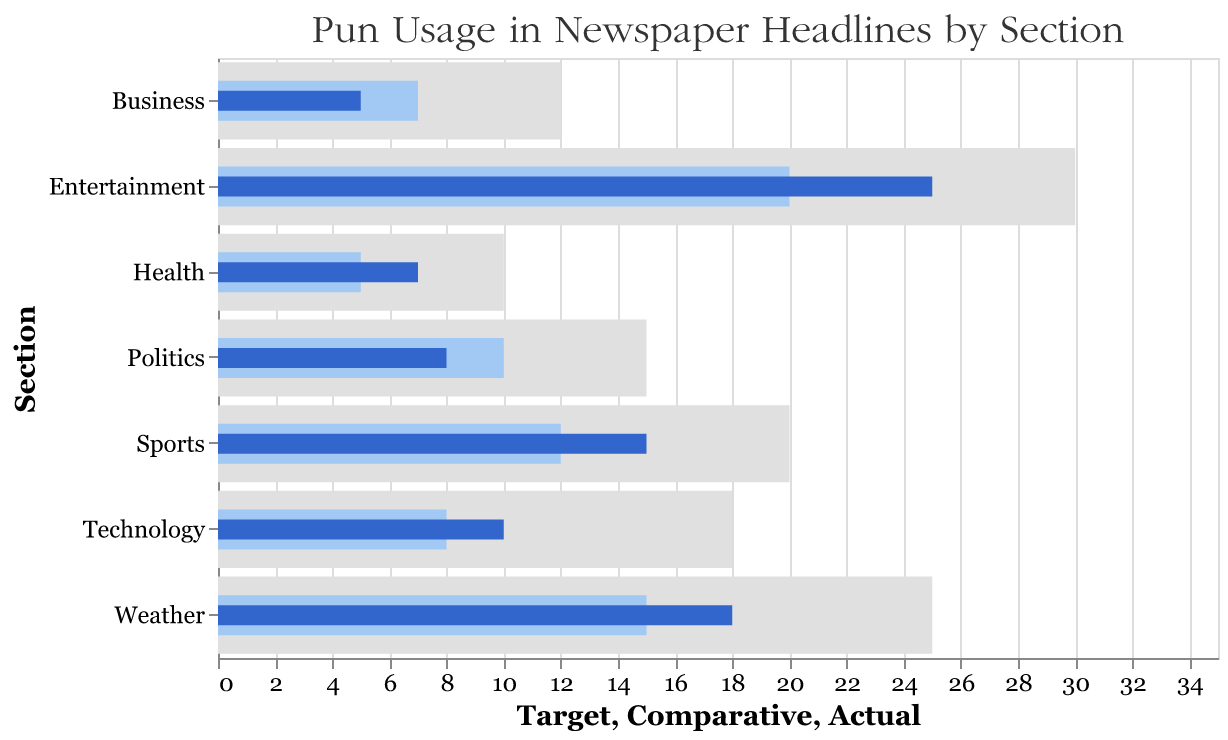What is the title of this figure? The title of the figure is usually displayed at the top of the chart. This title gives viewers a quick indication of what the chart represents.
Answer: Pun Usage in Newspaper Headlines by Section Which section has the highest actual pun usage? To find the section with the highest actual pun usage, you identify the tallest bar in the darkest color. In this chart, Entertainment has the highest actual bar value.
Answer: Entertainment How does the actual pun usage in Politics compare to the target for the same section? First, locate the bars for the Politics section. The actual usage is represented by the darkest bar (8), while the target is the background bar size (15). Compare these values directly.
Answer: It is lower In which section is the gap between comparative and actual pun usage the smallest? To determine this, identify the difference between comparative and actual values for each section and find the smallest difference. In Health, the comparative is 5, and the actual is 7, making the difference 2.
Answer: Health Which sections have an actual pun usage that exceeds their comparative pun usage? Identify sections where the darkest bar (actual usage) is longer than the lighter bar (comparative usage). This occurs in Sports and Health sections.
Answer: Sports, Health How does the actual pun usage in Technology compare to Business? Look at Technology and Business sections' actual pun usage values, represented by the darkest bars, which are 10 and 5, respectively.
Answer: Technology is higher What is the combined actual pun usage for Sports and Politics? Add the actual values for Sports (15) and Politics (8). The combined value is 15 + 8.
Answer: 23 Which section has the highest target for pun usage? Find the tallest bar representing the target values, which is the largest background bar. Entertainment has the highest target value of 30.
Answer: Entertainment What is the difference between Entertainment's actual and target pun usage? Subtract the actual value (25) from the target value (30) for Entertainment. The difference is 30 - 25.
Answer: 5 In which section is the comparative pun usage higher than the actual but less than the target? Identify sections where the comparative value is between the actual and target values. This is the case for Politics, Business, Weather, and Technology sections.
Answer: Politics, Business, Weather, Technology 